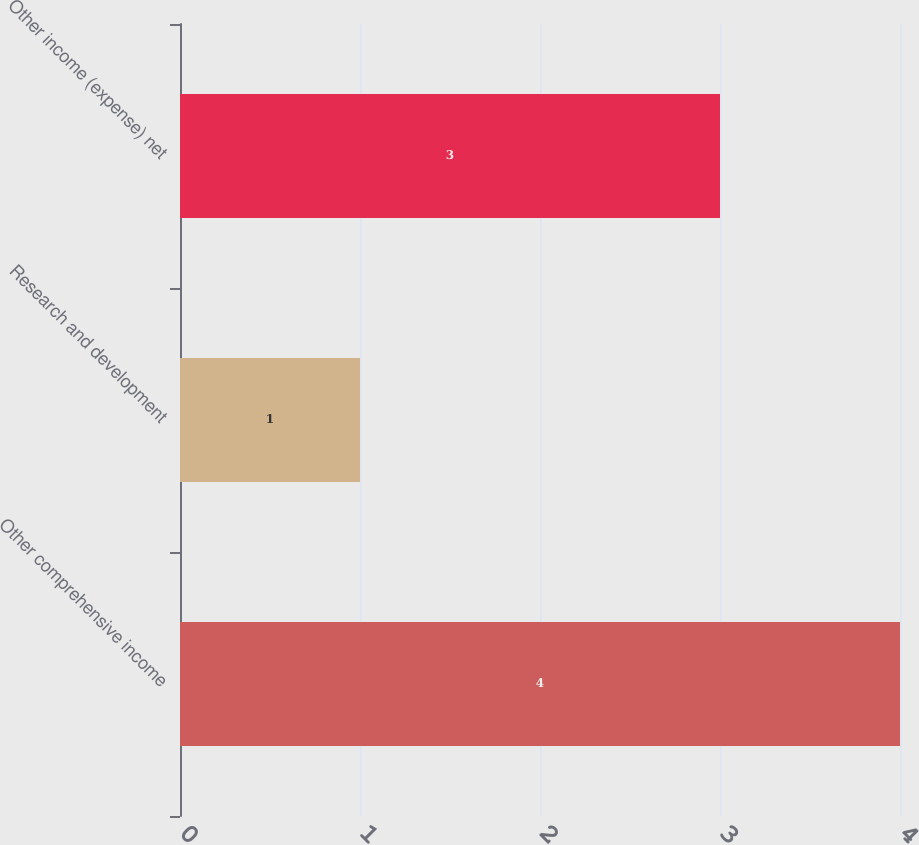<chart> <loc_0><loc_0><loc_500><loc_500><bar_chart><fcel>Other comprehensive income<fcel>Research and development<fcel>Other income (expense) net<nl><fcel>4<fcel>1<fcel>3<nl></chart> 